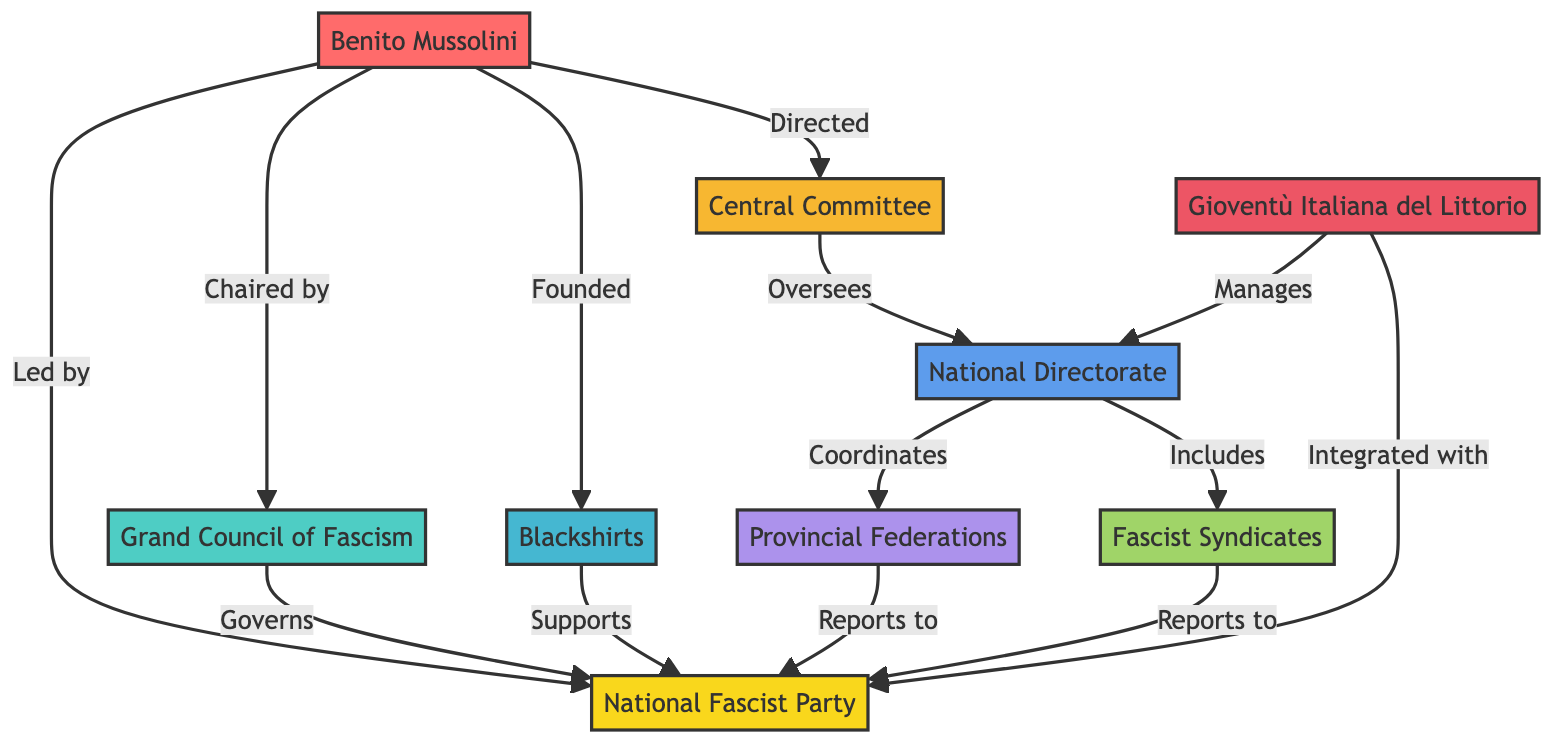What is the top organizational node in the diagram? The top organizational node in the diagram is the "National Fascist Party." This can be identified as it is prominently placed at the top of the diagram structure indicating its position as the leading entity in the organizational hierarchy.
Answer: National Fascist Party Who is the leader of the National Fascist Party? The leader of the National Fascist Party is "Benito Mussolini." This information is depicted in the diagram where Mussolini is directly connected to the National Fascist Party, indicating his role as the head of the organization.
Answer: Benito Mussolini How many main divisions are there in the National Fascist Party structure? There are seven main divisions in the party structure as indicated by the nodes branching out from the National Fascist Party. These divisions include the Grand Council of Fascism, Blackshirts, Central Committee, National Directorate, Provincial Federations, Fascist Syndicates, and Gioventù Italiana del Littorio.
Answer: Seven What role does the Grand Council of Fascism have in relation to the National Fascist Party? The Grand Council of Fascism "governs" the National Fascist Party. This is shown by the directed line connecting the Grand Council of Fascism to the National Fascist Party, illustrating its governance relationship.
Answer: Governs Which entity is chaired by Benito Mussolini? The "Grand Council of Fascism" is chaired by Benito Mussolini, as denoted by the connection in the diagram where he leads this specific entity.
Answer: Grand Council of Fascism What is the relationship between the National Directorate and the Provincial Federations? The National Directorate "coordinates" the Provincial Federations, as illustrated in the diagram by the directional flow showing that the National Directorate has oversight over the actions of the Provincial Federations within the structure of the party.
Answer: Coordinates How does the Gioventù Italiana del Littorio relate to the National Fascist Party? The Gioventù Italiana del Littorio is "integrated with" the National Fascist Party, as expressed by the link in the diagram indicating its direct association and inclusion within the broader party structure.
Answer: Integrated with What supports the National Fascist Party? The "Blackshirts" support the National Fascist Party, as stated in the diagram where a line connects the Blackshirts to the party, indicating their supportive role within the organization.
Answer: Blackshirts Which body oversees the National Directorate? The "Central Committee" oversees the National Directorate. This is evident from the directed relationship shown in the diagram indicating the Central Committee's authority over the National Directorate's functions and operations.
Answer: Central Committee 